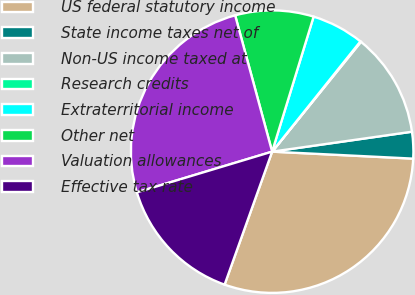Convert chart to OTSL. <chart><loc_0><loc_0><loc_500><loc_500><pie_chart><fcel>US federal statutory income<fcel>State income taxes net of<fcel>Non-US income taxed at<fcel>Research credits<fcel>Extraterritorial income<fcel>Other net<fcel>Valuation allowances<fcel>Effective tax rate<nl><fcel>29.67%<fcel>3.04%<fcel>11.92%<fcel>0.08%<fcel>6.0%<fcel>8.96%<fcel>25.43%<fcel>14.88%<nl></chart> 